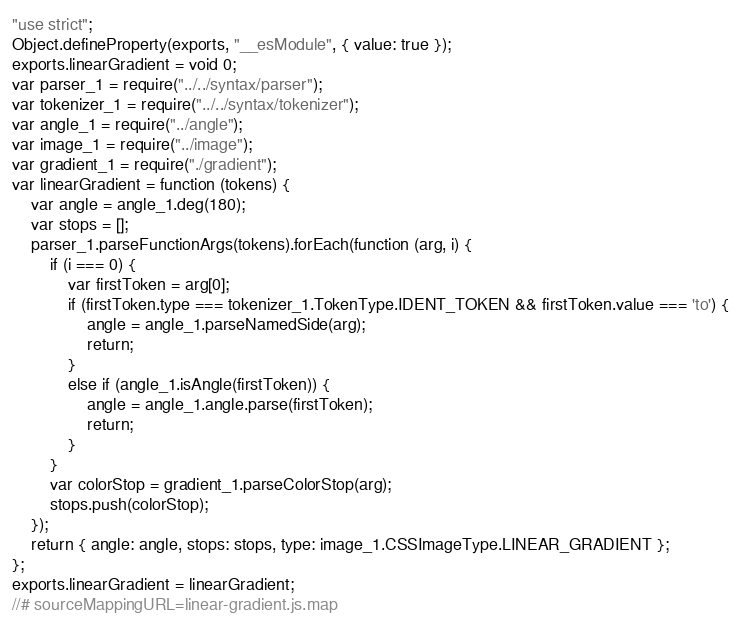Convert code to text. <code><loc_0><loc_0><loc_500><loc_500><_JavaScript_>"use strict";
Object.defineProperty(exports, "__esModule", { value: true });
exports.linearGradient = void 0;
var parser_1 = require("../../syntax/parser");
var tokenizer_1 = require("../../syntax/tokenizer");
var angle_1 = require("../angle");
var image_1 = require("../image");
var gradient_1 = require("./gradient");
var linearGradient = function (tokens) {
    var angle = angle_1.deg(180);
    var stops = [];
    parser_1.parseFunctionArgs(tokens).forEach(function (arg, i) {
        if (i === 0) {
            var firstToken = arg[0];
            if (firstToken.type === tokenizer_1.TokenType.IDENT_TOKEN && firstToken.value === 'to') {
                angle = angle_1.parseNamedSide(arg);
                return;
            }
            else if (angle_1.isAngle(firstToken)) {
                angle = angle_1.angle.parse(firstToken);
                return;
            }
        }
        var colorStop = gradient_1.parseColorStop(arg);
        stops.push(colorStop);
    });
    return { angle: angle, stops: stops, type: image_1.CSSImageType.LINEAR_GRADIENT };
};
exports.linearGradient = linearGradient;
//# sourceMappingURL=linear-gradient.js.map</code> 